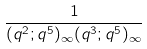<formula> <loc_0><loc_0><loc_500><loc_500>\frac { 1 } { ( q ^ { 2 } ; q ^ { 5 } ) _ { \infty } ( q ^ { 3 } ; q ^ { 5 } ) _ { \infty } }</formula> 